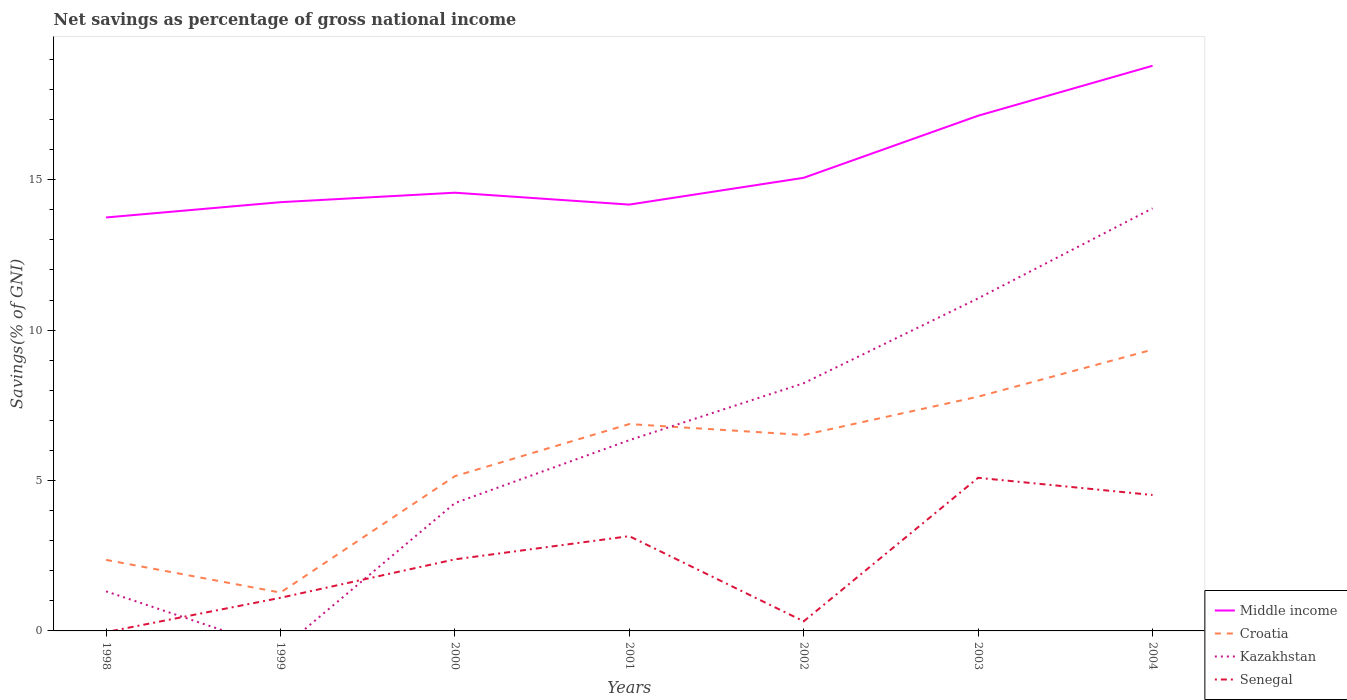Across all years, what is the maximum total savings in Middle income?
Your response must be concise. 13.74. What is the total total savings in Kazakhstan in the graph?
Give a very brief answer. -7.71. What is the difference between the highest and the second highest total savings in Middle income?
Provide a succinct answer. 5.04. Is the total savings in Croatia strictly greater than the total savings in Middle income over the years?
Keep it short and to the point. Yes. What is the difference between two consecutive major ticks on the Y-axis?
Your response must be concise. 5. How are the legend labels stacked?
Your answer should be compact. Vertical. What is the title of the graph?
Your answer should be compact. Net savings as percentage of gross national income. Does "Eritrea" appear as one of the legend labels in the graph?
Make the answer very short. No. What is the label or title of the X-axis?
Provide a short and direct response. Years. What is the label or title of the Y-axis?
Ensure brevity in your answer.  Savings(% of GNI). What is the Savings(% of GNI) of Middle income in 1998?
Provide a short and direct response. 13.74. What is the Savings(% of GNI) in Croatia in 1998?
Your answer should be very brief. 2.36. What is the Savings(% of GNI) of Kazakhstan in 1998?
Ensure brevity in your answer.  1.32. What is the Savings(% of GNI) of Senegal in 1998?
Give a very brief answer. 0. What is the Savings(% of GNI) in Middle income in 1999?
Keep it short and to the point. 14.25. What is the Savings(% of GNI) of Croatia in 1999?
Make the answer very short. 1.28. What is the Savings(% of GNI) of Kazakhstan in 1999?
Ensure brevity in your answer.  0. What is the Savings(% of GNI) in Senegal in 1999?
Provide a succinct answer. 1.1. What is the Savings(% of GNI) in Middle income in 2000?
Provide a succinct answer. 14.57. What is the Savings(% of GNI) in Croatia in 2000?
Keep it short and to the point. 5.14. What is the Savings(% of GNI) of Kazakhstan in 2000?
Give a very brief answer. 4.25. What is the Savings(% of GNI) in Senegal in 2000?
Keep it short and to the point. 2.38. What is the Savings(% of GNI) in Middle income in 2001?
Ensure brevity in your answer.  14.17. What is the Savings(% of GNI) of Croatia in 2001?
Offer a very short reply. 6.88. What is the Savings(% of GNI) in Kazakhstan in 2001?
Your answer should be very brief. 6.34. What is the Savings(% of GNI) of Senegal in 2001?
Your response must be concise. 3.15. What is the Savings(% of GNI) in Middle income in 2002?
Keep it short and to the point. 15.06. What is the Savings(% of GNI) of Croatia in 2002?
Make the answer very short. 6.51. What is the Savings(% of GNI) in Kazakhstan in 2002?
Give a very brief answer. 8.24. What is the Savings(% of GNI) in Senegal in 2002?
Your answer should be very brief. 0.32. What is the Savings(% of GNI) in Middle income in 2003?
Provide a succinct answer. 17.13. What is the Savings(% of GNI) of Croatia in 2003?
Provide a short and direct response. 7.79. What is the Savings(% of GNI) in Kazakhstan in 2003?
Your response must be concise. 11.06. What is the Savings(% of GNI) of Senegal in 2003?
Provide a succinct answer. 5.09. What is the Savings(% of GNI) of Middle income in 2004?
Your response must be concise. 18.79. What is the Savings(% of GNI) of Croatia in 2004?
Make the answer very short. 9.35. What is the Savings(% of GNI) in Kazakhstan in 2004?
Provide a short and direct response. 14.05. What is the Savings(% of GNI) of Senegal in 2004?
Provide a short and direct response. 4.52. Across all years, what is the maximum Savings(% of GNI) in Middle income?
Give a very brief answer. 18.79. Across all years, what is the maximum Savings(% of GNI) in Croatia?
Make the answer very short. 9.35. Across all years, what is the maximum Savings(% of GNI) of Kazakhstan?
Offer a very short reply. 14.05. Across all years, what is the maximum Savings(% of GNI) in Senegal?
Your answer should be compact. 5.09. Across all years, what is the minimum Savings(% of GNI) of Middle income?
Ensure brevity in your answer.  13.74. Across all years, what is the minimum Savings(% of GNI) of Croatia?
Make the answer very short. 1.28. What is the total Savings(% of GNI) of Middle income in the graph?
Make the answer very short. 107.72. What is the total Savings(% of GNI) in Croatia in the graph?
Provide a short and direct response. 39.31. What is the total Savings(% of GNI) in Kazakhstan in the graph?
Keep it short and to the point. 45.24. What is the total Savings(% of GNI) of Senegal in the graph?
Give a very brief answer. 16.56. What is the difference between the Savings(% of GNI) of Middle income in 1998 and that in 1999?
Your answer should be very brief. -0.51. What is the difference between the Savings(% of GNI) of Croatia in 1998 and that in 1999?
Offer a very short reply. 1.09. What is the difference between the Savings(% of GNI) in Middle income in 1998 and that in 2000?
Ensure brevity in your answer.  -0.82. What is the difference between the Savings(% of GNI) in Croatia in 1998 and that in 2000?
Your response must be concise. -2.78. What is the difference between the Savings(% of GNI) of Kazakhstan in 1998 and that in 2000?
Give a very brief answer. -2.93. What is the difference between the Savings(% of GNI) in Middle income in 1998 and that in 2001?
Your response must be concise. -0.43. What is the difference between the Savings(% of GNI) of Croatia in 1998 and that in 2001?
Make the answer very short. -4.52. What is the difference between the Savings(% of GNI) of Kazakhstan in 1998 and that in 2001?
Ensure brevity in your answer.  -5.02. What is the difference between the Savings(% of GNI) in Middle income in 1998 and that in 2002?
Ensure brevity in your answer.  -1.32. What is the difference between the Savings(% of GNI) of Croatia in 1998 and that in 2002?
Offer a terse response. -4.15. What is the difference between the Savings(% of GNI) in Kazakhstan in 1998 and that in 2002?
Your answer should be compact. -6.92. What is the difference between the Savings(% of GNI) in Middle income in 1998 and that in 2003?
Keep it short and to the point. -3.38. What is the difference between the Savings(% of GNI) in Croatia in 1998 and that in 2003?
Give a very brief answer. -5.43. What is the difference between the Savings(% of GNI) in Kazakhstan in 1998 and that in 2003?
Make the answer very short. -9.74. What is the difference between the Savings(% of GNI) in Middle income in 1998 and that in 2004?
Keep it short and to the point. -5.04. What is the difference between the Savings(% of GNI) of Croatia in 1998 and that in 2004?
Make the answer very short. -6.99. What is the difference between the Savings(% of GNI) of Kazakhstan in 1998 and that in 2004?
Offer a terse response. -12.73. What is the difference between the Savings(% of GNI) of Middle income in 1999 and that in 2000?
Provide a short and direct response. -0.32. What is the difference between the Savings(% of GNI) of Croatia in 1999 and that in 2000?
Make the answer very short. -3.87. What is the difference between the Savings(% of GNI) of Senegal in 1999 and that in 2000?
Offer a very short reply. -1.28. What is the difference between the Savings(% of GNI) in Croatia in 1999 and that in 2001?
Provide a short and direct response. -5.6. What is the difference between the Savings(% of GNI) of Senegal in 1999 and that in 2001?
Make the answer very short. -2.05. What is the difference between the Savings(% of GNI) in Middle income in 1999 and that in 2002?
Your response must be concise. -0.81. What is the difference between the Savings(% of GNI) of Croatia in 1999 and that in 2002?
Give a very brief answer. -5.24. What is the difference between the Savings(% of GNI) in Senegal in 1999 and that in 2002?
Provide a succinct answer. 0.78. What is the difference between the Savings(% of GNI) in Middle income in 1999 and that in 2003?
Give a very brief answer. -2.87. What is the difference between the Savings(% of GNI) in Croatia in 1999 and that in 2003?
Provide a short and direct response. -6.51. What is the difference between the Savings(% of GNI) of Senegal in 1999 and that in 2003?
Offer a very short reply. -3.99. What is the difference between the Savings(% of GNI) in Middle income in 1999 and that in 2004?
Offer a terse response. -4.53. What is the difference between the Savings(% of GNI) of Croatia in 1999 and that in 2004?
Make the answer very short. -8.08. What is the difference between the Savings(% of GNI) in Senegal in 1999 and that in 2004?
Your answer should be compact. -3.42. What is the difference between the Savings(% of GNI) in Middle income in 2000 and that in 2001?
Ensure brevity in your answer.  0.4. What is the difference between the Savings(% of GNI) of Croatia in 2000 and that in 2001?
Make the answer very short. -1.73. What is the difference between the Savings(% of GNI) of Kazakhstan in 2000 and that in 2001?
Provide a succinct answer. -2.09. What is the difference between the Savings(% of GNI) in Senegal in 2000 and that in 2001?
Offer a terse response. -0.77. What is the difference between the Savings(% of GNI) of Middle income in 2000 and that in 2002?
Offer a terse response. -0.5. What is the difference between the Savings(% of GNI) in Croatia in 2000 and that in 2002?
Ensure brevity in your answer.  -1.37. What is the difference between the Savings(% of GNI) in Kazakhstan in 2000 and that in 2002?
Provide a short and direct response. -3.99. What is the difference between the Savings(% of GNI) in Senegal in 2000 and that in 2002?
Offer a very short reply. 2.06. What is the difference between the Savings(% of GNI) of Middle income in 2000 and that in 2003?
Offer a very short reply. -2.56. What is the difference between the Savings(% of GNI) of Croatia in 2000 and that in 2003?
Give a very brief answer. -2.64. What is the difference between the Savings(% of GNI) of Kazakhstan in 2000 and that in 2003?
Provide a short and direct response. -6.81. What is the difference between the Savings(% of GNI) of Senegal in 2000 and that in 2003?
Offer a very short reply. -2.71. What is the difference between the Savings(% of GNI) of Middle income in 2000 and that in 2004?
Provide a short and direct response. -4.22. What is the difference between the Savings(% of GNI) of Croatia in 2000 and that in 2004?
Offer a very short reply. -4.21. What is the difference between the Savings(% of GNI) of Kazakhstan in 2000 and that in 2004?
Keep it short and to the point. -9.8. What is the difference between the Savings(% of GNI) in Senegal in 2000 and that in 2004?
Provide a succinct answer. -2.14. What is the difference between the Savings(% of GNI) of Middle income in 2001 and that in 2002?
Offer a terse response. -0.89. What is the difference between the Savings(% of GNI) in Croatia in 2001 and that in 2002?
Ensure brevity in your answer.  0.36. What is the difference between the Savings(% of GNI) in Kazakhstan in 2001 and that in 2002?
Ensure brevity in your answer.  -1.89. What is the difference between the Savings(% of GNI) of Senegal in 2001 and that in 2002?
Give a very brief answer. 2.83. What is the difference between the Savings(% of GNI) in Middle income in 2001 and that in 2003?
Offer a terse response. -2.95. What is the difference between the Savings(% of GNI) of Croatia in 2001 and that in 2003?
Offer a terse response. -0.91. What is the difference between the Savings(% of GNI) in Kazakhstan in 2001 and that in 2003?
Provide a short and direct response. -4.71. What is the difference between the Savings(% of GNI) of Senegal in 2001 and that in 2003?
Offer a terse response. -1.94. What is the difference between the Savings(% of GNI) of Middle income in 2001 and that in 2004?
Provide a short and direct response. -4.61. What is the difference between the Savings(% of GNI) in Croatia in 2001 and that in 2004?
Offer a very short reply. -2.47. What is the difference between the Savings(% of GNI) in Kazakhstan in 2001 and that in 2004?
Provide a short and direct response. -7.71. What is the difference between the Savings(% of GNI) of Senegal in 2001 and that in 2004?
Make the answer very short. -1.37. What is the difference between the Savings(% of GNI) of Middle income in 2002 and that in 2003?
Offer a terse response. -2.06. What is the difference between the Savings(% of GNI) of Croatia in 2002 and that in 2003?
Make the answer very short. -1.27. What is the difference between the Savings(% of GNI) in Kazakhstan in 2002 and that in 2003?
Offer a terse response. -2.82. What is the difference between the Savings(% of GNI) in Senegal in 2002 and that in 2003?
Your answer should be compact. -4.77. What is the difference between the Savings(% of GNI) of Middle income in 2002 and that in 2004?
Make the answer very short. -3.72. What is the difference between the Savings(% of GNI) in Croatia in 2002 and that in 2004?
Make the answer very short. -2.84. What is the difference between the Savings(% of GNI) of Kazakhstan in 2002 and that in 2004?
Make the answer very short. -5.81. What is the difference between the Savings(% of GNI) in Senegal in 2002 and that in 2004?
Give a very brief answer. -4.2. What is the difference between the Savings(% of GNI) of Middle income in 2003 and that in 2004?
Offer a very short reply. -1.66. What is the difference between the Savings(% of GNI) in Croatia in 2003 and that in 2004?
Provide a short and direct response. -1.56. What is the difference between the Savings(% of GNI) in Kazakhstan in 2003 and that in 2004?
Keep it short and to the point. -2.99. What is the difference between the Savings(% of GNI) of Senegal in 2003 and that in 2004?
Keep it short and to the point. 0.57. What is the difference between the Savings(% of GNI) in Middle income in 1998 and the Savings(% of GNI) in Croatia in 1999?
Ensure brevity in your answer.  12.47. What is the difference between the Savings(% of GNI) of Middle income in 1998 and the Savings(% of GNI) of Senegal in 1999?
Your response must be concise. 12.64. What is the difference between the Savings(% of GNI) of Croatia in 1998 and the Savings(% of GNI) of Senegal in 1999?
Your answer should be very brief. 1.26. What is the difference between the Savings(% of GNI) of Kazakhstan in 1998 and the Savings(% of GNI) of Senegal in 1999?
Your response must be concise. 0.22. What is the difference between the Savings(% of GNI) in Middle income in 1998 and the Savings(% of GNI) in Croatia in 2000?
Give a very brief answer. 8.6. What is the difference between the Savings(% of GNI) of Middle income in 1998 and the Savings(% of GNI) of Kazakhstan in 2000?
Ensure brevity in your answer.  9.5. What is the difference between the Savings(% of GNI) in Middle income in 1998 and the Savings(% of GNI) in Senegal in 2000?
Provide a succinct answer. 11.37. What is the difference between the Savings(% of GNI) in Croatia in 1998 and the Savings(% of GNI) in Kazakhstan in 2000?
Your answer should be very brief. -1.89. What is the difference between the Savings(% of GNI) of Croatia in 1998 and the Savings(% of GNI) of Senegal in 2000?
Make the answer very short. -0.02. What is the difference between the Savings(% of GNI) in Kazakhstan in 1998 and the Savings(% of GNI) in Senegal in 2000?
Provide a short and direct response. -1.06. What is the difference between the Savings(% of GNI) of Middle income in 1998 and the Savings(% of GNI) of Croatia in 2001?
Your response must be concise. 6.87. What is the difference between the Savings(% of GNI) of Middle income in 1998 and the Savings(% of GNI) of Kazakhstan in 2001?
Offer a terse response. 7.4. What is the difference between the Savings(% of GNI) in Middle income in 1998 and the Savings(% of GNI) in Senegal in 2001?
Your answer should be very brief. 10.59. What is the difference between the Savings(% of GNI) in Croatia in 1998 and the Savings(% of GNI) in Kazakhstan in 2001?
Your response must be concise. -3.98. What is the difference between the Savings(% of GNI) in Croatia in 1998 and the Savings(% of GNI) in Senegal in 2001?
Your response must be concise. -0.79. What is the difference between the Savings(% of GNI) of Kazakhstan in 1998 and the Savings(% of GNI) of Senegal in 2001?
Offer a very short reply. -1.83. What is the difference between the Savings(% of GNI) of Middle income in 1998 and the Savings(% of GNI) of Croatia in 2002?
Provide a succinct answer. 7.23. What is the difference between the Savings(% of GNI) in Middle income in 1998 and the Savings(% of GNI) in Kazakhstan in 2002?
Give a very brief answer. 5.51. What is the difference between the Savings(% of GNI) of Middle income in 1998 and the Savings(% of GNI) of Senegal in 2002?
Ensure brevity in your answer.  13.43. What is the difference between the Savings(% of GNI) in Croatia in 1998 and the Savings(% of GNI) in Kazakhstan in 2002?
Offer a very short reply. -5.87. What is the difference between the Savings(% of GNI) in Croatia in 1998 and the Savings(% of GNI) in Senegal in 2002?
Give a very brief answer. 2.04. What is the difference between the Savings(% of GNI) in Kazakhstan in 1998 and the Savings(% of GNI) in Senegal in 2002?
Give a very brief answer. 1. What is the difference between the Savings(% of GNI) in Middle income in 1998 and the Savings(% of GNI) in Croatia in 2003?
Offer a very short reply. 5.96. What is the difference between the Savings(% of GNI) in Middle income in 1998 and the Savings(% of GNI) in Kazakhstan in 2003?
Your answer should be very brief. 2.69. What is the difference between the Savings(% of GNI) of Middle income in 1998 and the Savings(% of GNI) of Senegal in 2003?
Your answer should be very brief. 8.65. What is the difference between the Savings(% of GNI) of Croatia in 1998 and the Savings(% of GNI) of Kazakhstan in 2003?
Your answer should be compact. -8.69. What is the difference between the Savings(% of GNI) of Croatia in 1998 and the Savings(% of GNI) of Senegal in 2003?
Give a very brief answer. -2.73. What is the difference between the Savings(% of GNI) in Kazakhstan in 1998 and the Savings(% of GNI) in Senegal in 2003?
Offer a terse response. -3.77. What is the difference between the Savings(% of GNI) in Middle income in 1998 and the Savings(% of GNI) in Croatia in 2004?
Your answer should be compact. 4.39. What is the difference between the Savings(% of GNI) of Middle income in 1998 and the Savings(% of GNI) of Kazakhstan in 2004?
Provide a succinct answer. -0.3. What is the difference between the Savings(% of GNI) of Middle income in 1998 and the Savings(% of GNI) of Senegal in 2004?
Keep it short and to the point. 9.23. What is the difference between the Savings(% of GNI) of Croatia in 1998 and the Savings(% of GNI) of Kazakhstan in 2004?
Give a very brief answer. -11.69. What is the difference between the Savings(% of GNI) in Croatia in 1998 and the Savings(% of GNI) in Senegal in 2004?
Your response must be concise. -2.16. What is the difference between the Savings(% of GNI) of Kazakhstan in 1998 and the Savings(% of GNI) of Senegal in 2004?
Keep it short and to the point. -3.2. What is the difference between the Savings(% of GNI) in Middle income in 1999 and the Savings(% of GNI) in Croatia in 2000?
Make the answer very short. 9.11. What is the difference between the Savings(% of GNI) in Middle income in 1999 and the Savings(% of GNI) in Kazakhstan in 2000?
Give a very brief answer. 10. What is the difference between the Savings(% of GNI) in Middle income in 1999 and the Savings(% of GNI) in Senegal in 2000?
Your answer should be compact. 11.87. What is the difference between the Savings(% of GNI) of Croatia in 1999 and the Savings(% of GNI) of Kazakhstan in 2000?
Make the answer very short. -2.97. What is the difference between the Savings(% of GNI) in Croatia in 1999 and the Savings(% of GNI) in Senegal in 2000?
Ensure brevity in your answer.  -1.1. What is the difference between the Savings(% of GNI) of Middle income in 1999 and the Savings(% of GNI) of Croatia in 2001?
Your response must be concise. 7.38. What is the difference between the Savings(% of GNI) of Middle income in 1999 and the Savings(% of GNI) of Kazakhstan in 2001?
Your response must be concise. 7.91. What is the difference between the Savings(% of GNI) of Middle income in 1999 and the Savings(% of GNI) of Senegal in 2001?
Keep it short and to the point. 11.1. What is the difference between the Savings(% of GNI) of Croatia in 1999 and the Savings(% of GNI) of Kazakhstan in 2001?
Your answer should be compact. -5.07. What is the difference between the Savings(% of GNI) of Croatia in 1999 and the Savings(% of GNI) of Senegal in 2001?
Your answer should be very brief. -1.88. What is the difference between the Savings(% of GNI) in Middle income in 1999 and the Savings(% of GNI) in Croatia in 2002?
Make the answer very short. 7.74. What is the difference between the Savings(% of GNI) of Middle income in 1999 and the Savings(% of GNI) of Kazakhstan in 2002?
Give a very brief answer. 6.02. What is the difference between the Savings(% of GNI) in Middle income in 1999 and the Savings(% of GNI) in Senegal in 2002?
Ensure brevity in your answer.  13.93. What is the difference between the Savings(% of GNI) of Croatia in 1999 and the Savings(% of GNI) of Kazakhstan in 2002?
Your answer should be very brief. -6.96. What is the difference between the Savings(% of GNI) in Croatia in 1999 and the Savings(% of GNI) in Senegal in 2002?
Provide a short and direct response. 0.96. What is the difference between the Savings(% of GNI) in Middle income in 1999 and the Savings(% of GNI) in Croatia in 2003?
Make the answer very short. 6.47. What is the difference between the Savings(% of GNI) of Middle income in 1999 and the Savings(% of GNI) of Kazakhstan in 2003?
Provide a short and direct response. 3.2. What is the difference between the Savings(% of GNI) of Middle income in 1999 and the Savings(% of GNI) of Senegal in 2003?
Keep it short and to the point. 9.16. What is the difference between the Savings(% of GNI) of Croatia in 1999 and the Savings(% of GNI) of Kazakhstan in 2003?
Offer a terse response. -9.78. What is the difference between the Savings(% of GNI) in Croatia in 1999 and the Savings(% of GNI) in Senegal in 2003?
Your response must be concise. -3.82. What is the difference between the Savings(% of GNI) of Middle income in 1999 and the Savings(% of GNI) of Croatia in 2004?
Provide a succinct answer. 4.9. What is the difference between the Savings(% of GNI) of Middle income in 1999 and the Savings(% of GNI) of Kazakhstan in 2004?
Your response must be concise. 0.21. What is the difference between the Savings(% of GNI) in Middle income in 1999 and the Savings(% of GNI) in Senegal in 2004?
Offer a very short reply. 9.73. What is the difference between the Savings(% of GNI) in Croatia in 1999 and the Savings(% of GNI) in Kazakhstan in 2004?
Keep it short and to the point. -12.77. What is the difference between the Savings(% of GNI) of Croatia in 1999 and the Savings(% of GNI) of Senegal in 2004?
Provide a succinct answer. -3.24. What is the difference between the Savings(% of GNI) of Middle income in 2000 and the Savings(% of GNI) of Croatia in 2001?
Offer a terse response. 7.69. What is the difference between the Savings(% of GNI) of Middle income in 2000 and the Savings(% of GNI) of Kazakhstan in 2001?
Ensure brevity in your answer.  8.23. What is the difference between the Savings(% of GNI) of Middle income in 2000 and the Savings(% of GNI) of Senegal in 2001?
Offer a very short reply. 11.42. What is the difference between the Savings(% of GNI) of Croatia in 2000 and the Savings(% of GNI) of Kazakhstan in 2001?
Give a very brief answer. -1.2. What is the difference between the Savings(% of GNI) in Croatia in 2000 and the Savings(% of GNI) in Senegal in 2001?
Offer a very short reply. 1.99. What is the difference between the Savings(% of GNI) in Kazakhstan in 2000 and the Savings(% of GNI) in Senegal in 2001?
Offer a terse response. 1.1. What is the difference between the Savings(% of GNI) in Middle income in 2000 and the Savings(% of GNI) in Croatia in 2002?
Your answer should be very brief. 8.05. What is the difference between the Savings(% of GNI) in Middle income in 2000 and the Savings(% of GNI) in Kazakhstan in 2002?
Offer a very short reply. 6.33. What is the difference between the Savings(% of GNI) in Middle income in 2000 and the Savings(% of GNI) in Senegal in 2002?
Your answer should be compact. 14.25. What is the difference between the Savings(% of GNI) of Croatia in 2000 and the Savings(% of GNI) of Kazakhstan in 2002?
Keep it short and to the point. -3.09. What is the difference between the Savings(% of GNI) of Croatia in 2000 and the Savings(% of GNI) of Senegal in 2002?
Give a very brief answer. 4.83. What is the difference between the Savings(% of GNI) of Kazakhstan in 2000 and the Savings(% of GNI) of Senegal in 2002?
Ensure brevity in your answer.  3.93. What is the difference between the Savings(% of GNI) in Middle income in 2000 and the Savings(% of GNI) in Croatia in 2003?
Make the answer very short. 6.78. What is the difference between the Savings(% of GNI) in Middle income in 2000 and the Savings(% of GNI) in Kazakhstan in 2003?
Your answer should be very brief. 3.51. What is the difference between the Savings(% of GNI) of Middle income in 2000 and the Savings(% of GNI) of Senegal in 2003?
Make the answer very short. 9.48. What is the difference between the Savings(% of GNI) of Croatia in 2000 and the Savings(% of GNI) of Kazakhstan in 2003?
Ensure brevity in your answer.  -5.91. What is the difference between the Savings(% of GNI) of Croatia in 2000 and the Savings(% of GNI) of Senegal in 2003?
Offer a very short reply. 0.05. What is the difference between the Savings(% of GNI) of Kazakhstan in 2000 and the Savings(% of GNI) of Senegal in 2003?
Your answer should be very brief. -0.84. What is the difference between the Savings(% of GNI) of Middle income in 2000 and the Savings(% of GNI) of Croatia in 2004?
Provide a succinct answer. 5.22. What is the difference between the Savings(% of GNI) of Middle income in 2000 and the Savings(% of GNI) of Kazakhstan in 2004?
Keep it short and to the point. 0.52. What is the difference between the Savings(% of GNI) in Middle income in 2000 and the Savings(% of GNI) in Senegal in 2004?
Offer a very short reply. 10.05. What is the difference between the Savings(% of GNI) in Croatia in 2000 and the Savings(% of GNI) in Kazakhstan in 2004?
Provide a short and direct response. -8.9. What is the difference between the Savings(% of GNI) in Croatia in 2000 and the Savings(% of GNI) in Senegal in 2004?
Give a very brief answer. 0.63. What is the difference between the Savings(% of GNI) of Kazakhstan in 2000 and the Savings(% of GNI) of Senegal in 2004?
Offer a terse response. -0.27. What is the difference between the Savings(% of GNI) in Middle income in 2001 and the Savings(% of GNI) in Croatia in 2002?
Give a very brief answer. 7.66. What is the difference between the Savings(% of GNI) in Middle income in 2001 and the Savings(% of GNI) in Kazakhstan in 2002?
Your answer should be very brief. 5.94. What is the difference between the Savings(% of GNI) in Middle income in 2001 and the Savings(% of GNI) in Senegal in 2002?
Your response must be concise. 13.85. What is the difference between the Savings(% of GNI) in Croatia in 2001 and the Savings(% of GNI) in Kazakhstan in 2002?
Offer a terse response. -1.36. What is the difference between the Savings(% of GNI) of Croatia in 2001 and the Savings(% of GNI) of Senegal in 2002?
Provide a short and direct response. 6.56. What is the difference between the Savings(% of GNI) of Kazakhstan in 2001 and the Savings(% of GNI) of Senegal in 2002?
Ensure brevity in your answer.  6.02. What is the difference between the Savings(% of GNI) of Middle income in 2001 and the Savings(% of GNI) of Croatia in 2003?
Keep it short and to the point. 6.39. What is the difference between the Savings(% of GNI) of Middle income in 2001 and the Savings(% of GNI) of Kazakhstan in 2003?
Give a very brief answer. 3.12. What is the difference between the Savings(% of GNI) of Middle income in 2001 and the Savings(% of GNI) of Senegal in 2003?
Your answer should be compact. 9.08. What is the difference between the Savings(% of GNI) of Croatia in 2001 and the Savings(% of GNI) of Kazakhstan in 2003?
Your response must be concise. -4.18. What is the difference between the Savings(% of GNI) in Croatia in 2001 and the Savings(% of GNI) in Senegal in 2003?
Keep it short and to the point. 1.79. What is the difference between the Savings(% of GNI) of Kazakhstan in 2001 and the Savings(% of GNI) of Senegal in 2003?
Keep it short and to the point. 1.25. What is the difference between the Savings(% of GNI) of Middle income in 2001 and the Savings(% of GNI) of Croatia in 2004?
Give a very brief answer. 4.82. What is the difference between the Savings(% of GNI) in Middle income in 2001 and the Savings(% of GNI) in Kazakhstan in 2004?
Your answer should be compact. 0.13. What is the difference between the Savings(% of GNI) in Middle income in 2001 and the Savings(% of GNI) in Senegal in 2004?
Your response must be concise. 9.65. What is the difference between the Savings(% of GNI) of Croatia in 2001 and the Savings(% of GNI) of Kazakhstan in 2004?
Keep it short and to the point. -7.17. What is the difference between the Savings(% of GNI) of Croatia in 2001 and the Savings(% of GNI) of Senegal in 2004?
Your response must be concise. 2.36. What is the difference between the Savings(% of GNI) of Kazakhstan in 2001 and the Savings(% of GNI) of Senegal in 2004?
Give a very brief answer. 1.82. What is the difference between the Savings(% of GNI) of Middle income in 2002 and the Savings(% of GNI) of Croatia in 2003?
Your answer should be compact. 7.28. What is the difference between the Savings(% of GNI) of Middle income in 2002 and the Savings(% of GNI) of Kazakhstan in 2003?
Ensure brevity in your answer.  4.01. What is the difference between the Savings(% of GNI) of Middle income in 2002 and the Savings(% of GNI) of Senegal in 2003?
Provide a short and direct response. 9.97. What is the difference between the Savings(% of GNI) of Croatia in 2002 and the Savings(% of GNI) of Kazakhstan in 2003?
Make the answer very short. -4.54. What is the difference between the Savings(% of GNI) of Croatia in 2002 and the Savings(% of GNI) of Senegal in 2003?
Your answer should be compact. 1.42. What is the difference between the Savings(% of GNI) in Kazakhstan in 2002 and the Savings(% of GNI) in Senegal in 2003?
Ensure brevity in your answer.  3.14. What is the difference between the Savings(% of GNI) in Middle income in 2002 and the Savings(% of GNI) in Croatia in 2004?
Provide a short and direct response. 5.71. What is the difference between the Savings(% of GNI) of Middle income in 2002 and the Savings(% of GNI) of Kazakhstan in 2004?
Offer a terse response. 1.02. What is the difference between the Savings(% of GNI) in Middle income in 2002 and the Savings(% of GNI) in Senegal in 2004?
Provide a succinct answer. 10.54. What is the difference between the Savings(% of GNI) in Croatia in 2002 and the Savings(% of GNI) in Kazakhstan in 2004?
Your response must be concise. -7.53. What is the difference between the Savings(% of GNI) of Croatia in 2002 and the Savings(% of GNI) of Senegal in 2004?
Ensure brevity in your answer.  2. What is the difference between the Savings(% of GNI) of Kazakhstan in 2002 and the Savings(% of GNI) of Senegal in 2004?
Keep it short and to the point. 3.72. What is the difference between the Savings(% of GNI) in Middle income in 2003 and the Savings(% of GNI) in Croatia in 2004?
Provide a short and direct response. 7.78. What is the difference between the Savings(% of GNI) in Middle income in 2003 and the Savings(% of GNI) in Kazakhstan in 2004?
Your answer should be compact. 3.08. What is the difference between the Savings(% of GNI) in Middle income in 2003 and the Savings(% of GNI) in Senegal in 2004?
Provide a succinct answer. 12.61. What is the difference between the Savings(% of GNI) of Croatia in 2003 and the Savings(% of GNI) of Kazakhstan in 2004?
Your answer should be compact. -6.26. What is the difference between the Savings(% of GNI) in Croatia in 2003 and the Savings(% of GNI) in Senegal in 2004?
Your answer should be compact. 3.27. What is the difference between the Savings(% of GNI) in Kazakhstan in 2003 and the Savings(% of GNI) in Senegal in 2004?
Give a very brief answer. 6.54. What is the average Savings(% of GNI) of Middle income per year?
Your answer should be compact. 15.39. What is the average Savings(% of GNI) of Croatia per year?
Provide a succinct answer. 5.62. What is the average Savings(% of GNI) of Kazakhstan per year?
Make the answer very short. 6.46. What is the average Savings(% of GNI) in Senegal per year?
Provide a succinct answer. 2.37. In the year 1998, what is the difference between the Savings(% of GNI) in Middle income and Savings(% of GNI) in Croatia?
Ensure brevity in your answer.  11.38. In the year 1998, what is the difference between the Savings(% of GNI) in Middle income and Savings(% of GNI) in Kazakhstan?
Provide a succinct answer. 12.43. In the year 1998, what is the difference between the Savings(% of GNI) in Croatia and Savings(% of GNI) in Kazakhstan?
Provide a succinct answer. 1.05. In the year 1999, what is the difference between the Savings(% of GNI) in Middle income and Savings(% of GNI) in Croatia?
Provide a succinct answer. 12.98. In the year 1999, what is the difference between the Savings(% of GNI) of Middle income and Savings(% of GNI) of Senegal?
Offer a terse response. 13.15. In the year 1999, what is the difference between the Savings(% of GNI) in Croatia and Savings(% of GNI) in Senegal?
Keep it short and to the point. 0.17. In the year 2000, what is the difference between the Savings(% of GNI) in Middle income and Savings(% of GNI) in Croatia?
Offer a terse response. 9.42. In the year 2000, what is the difference between the Savings(% of GNI) in Middle income and Savings(% of GNI) in Kazakhstan?
Offer a terse response. 10.32. In the year 2000, what is the difference between the Savings(% of GNI) in Middle income and Savings(% of GNI) in Senegal?
Offer a terse response. 12.19. In the year 2000, what is the difference between the Savings(% of GNI) of Croatia and Savings(% of GNI) of Kazakhstan?
Provide a succinct answer. 0.9. In the year 2000, what is the difference between the Savings(% of GNI) of Croatia and Savings(% of GNI) of Senegal?
Offer a terse response. 2.76. In the year 2000, what is the difference between the Savings(% of GNI) in Kazakhstan and Savings(% of GNI) in Senegal?
Keep it short and to the point. 1.87. In the year 2001, what is the difference between the Savings(% of GNI) of Middle income and Savings(% of GNI) of Croatia?
Provide a succinct answer. 7.3. In the year 2001, what is the difference between the Savings(% of GNI) in Middle income and Savings(% of GNI) in Kazakhstan?
Your answer should be compact. 7.83. In the year 2001, what is the difference between the Savings(% of GNI) in Middle income and Savings(% of GNI) in Senegal?
Offer a terse response. 11.02. In the year 2001, what is the difference between the Savings(% of GNI) of Croatia and Savings(% of GNI) of Kazakhstan?
Give a very brief answer. 0.54. In the year 2001, what is the difference between the Savings(% of GNI) in Croatia and Savings(% of GNI) in Senegal?
Your response must be concise. 3.73. In the year 2001, what is the difference between the Savings(% of GNI) in Kazakhstan and Savings(% of GNI) in Senegal?
Provide a short and direct response. 3.19. In the year 2002, what is the difference between the Savings(% of GNI) in Middle income and Savings(% of GNI) in Croatia?
Your answer should be very brief. 8.55. In the year 2002, what is the difference between the Savings(% of GNI) in Middle income and Savings(% of GNI) in Kazakhstan?
Keep it short and to the point. 6.83. In the year 2002, what is the difference between the Savings(% of GNI) in Middle income and Savings(% of GNI) in Senegal?
Provide a short and direct response. 14.75. In the year 2002, what is the difference between the Savings(% of GNI) in Croatia and Savings(% of GNI) in Kazakhstan?
Offer a very short reply. -1.72. In the year 2002, what is the difference between the Savings(% of GNI) of Croatia and Savings(% of GNI) of Senegal?
Keep it short and to the point. 6.2. In the year 2002, what is the difference between the Savings(% of GNI) of Kazakhstan and Savings(% of GNI) of Senegal?
Keep it short and to the point. 7.92. In the year 2003, what is the difference between the Savings(% of GNI) in Middle income and Savings(% of GNI) in Croatia?
Your response must be concise. 9.34. In the year 2003, what is the difference between the Savings(% of GNI) in Middle income and Savings(% of GNI) in Kazakhstan?
Offer a very short reply. 6.07. In the year 2003, what is the difference between the Savings(% of GNI) in Middle income and Savings(% of GNI) in Senegal?
Provide a succinct answer. 12.04. In the year 2003, what is the difference between the Savings(% of GNI) of Croatia and Savings(% of GNI) of Kazakhstan?
Make the answer very short. -3.27. In the year 2003, what is the difference between the Savings(% of GNI) of Croatia and Savings(% of GNI) of Senegal?
Provide a short and direct response. 2.7. In the year 2003, what is the difference between the Savings(% of GNI) of Kazakhstan and Savings(% of GNI) of Senegal?
Provide a succinct answer. 5.97. In the year 2004, what is the difference between the Savings(% of GNI) of Middle income and Savings(% of GNI) of Croatia?
Make the answer very short. 9.44. In the year 2004, what is the difference between the Savings(% of GNI) in Middle income and Savings(% of GNI) in Kazakhstan?
Give a very brief answer. 4.74. In the year 2004, what is the difference between the Savings(% of GNI) in Middle income and Savings(% of GNI) in Senegal?
Your answer should be very brief. 14.27. In the year 2004, what is the difference between the Savings(% of GNI) of Croatia and Savings(% of GNI) of Kazakhstan?
Ensure brevity in your answer.  -4.7. In the year 2004, what is the difference between the Savings(% of GNI) in Croatia and Savings(% of GNI) in Senegal?
Provide a short and direct response. 4.83. In the year 2004, what is the difference between the Savings(% of GNI) in Kazakhstan and Savings(% of GNI) in Senegal?
Provide a succinct answer. 9.53. What is the ratio of the Savings(% of GNI) of Middle income in 1998 to that in 1999?
Your answer should be very brief. 0.96. What is the ratio of the Savings(% of GNI) in Croatia in 1998 to that in 1999?
Provide a short and direct response. 1.85. What is the ratio of the Savings(% of GNI) in Middle income in 1998 to that in 2000?
Your response must be concise. 0.94. What is the ratio of the Savings(% of GNI) of Croatia in 1998 to that in 2000?
Your answer should be compact. 0.46. What is the ratio of the Savings(% of GNI) in Kazakhstan in 1998 to that in 2000?
Your answer should be compact. 0.31. What is the ratio of the Savings(% of GNI) of Middle income in 1998 to that in 2001?
Offer a terse response. 0.97. What is the ratio of the Savings(% of GNI) of Croatia in 1998 to that in 2001?
Give a very brief answer. 0.34. What is the ratio of the Savings(% of GNI) in Kazakhstan in 1998 to that in 2001?
Offer a terse response. 0.21. What is the ratio of the Savings(% of GNI) of Middle income in 1998 to that in 2002?
Provide a succinct answer. 0.91. What is the ratio of the Savings(% of GNI) in Croatia in 1998 to that in 2002?
Offer a very short reply. 0.36. What is the ratio of the Savings(% of GNI) of Kazakhstan in 1998 to that in 2002?
Your answer should be compact. 0.16. What is the ratio of the Savings(% of GNI) in Middle income in 1998 to that in 2003?
Your answer should be compact. 0.8. What is the ratio of the Savings(% of GNI) in Croatia in 1998 to that in 2003?
Your answer should be very brief. 0.3. What is the ratio of the Savings(% of GNI) of Kazakhstan in 1998 to that in 2003?
Keep it short and to the point. 0.12. What is the ratio of the Savings(% of GNI) in Middle income in 1998 to that in 2004?
Provide a succinct answer. 0.73. What is the ratio of the Savings(% of GNI) in Croatia in 1998 to that in 2004?
Offer a terse response. 0.25. What is the ratio of the Savings(% of GNI) in Kazakhstan in 1998 to that in 2004?
Ensure brevity in your answer.  0.09. What is the ratio of the Savings(% of GNI) in Middle income in 1999 to that in 2000?
Your answer should be compact. 0.98. What is the ratio of the Savings(% of GNI) in Croatia in 1999 to that in 2000?
Make the answer very short. 0.25. What is the ratio of the Savings(% of GNI) of Senegal in 1999 to that in 2000?
Your answer should be compact. 0.46. What is the ratio of the Savings(% of GNI) of Middle income in 1999 to that in 2001?
Provide a short and direct response. 1.01. What is the ratio of the Savings(% of GNI) of Croatia in 1999 to that in 2001?
Your response must be concise. 0.19. What is the ratio of the Savings(% of GNI) of Senegal in 1999 to that in 2001?
Your response must be concise. 0.35. What is the ratio of the Savings(% of GNI) of Middle income in 1999 to that in 2002?
Provide a short and direct response. 0.95. What is the ratio of the Savings(% of GNI) in Croatia in 1999 to that in 2002?
Ensure brevity in your answer.  0.2. What is the ratio of the Savings(% of GNI) of Senegal in 1999 to that in 2002?
Your answer should be compact. 3.46. What is the ratio of the Savings(% of GNI) in Middle income in 1999 to that in 2003?
Your answer should be compact. 0.83. What is the ratio of the Savings(% of GNI) of Croatia in 1999 to that in 2003?
Your answer should be compact. 0.16. What is the ratio of the Savings(% of GNI) in Senegal in 1999 to that in 2003?
Offer a very short reply. 0.22. What is the ratio of the Savings(% of GNI) in Middle income in 1999 to that in 2004?
Your response must be concise. 0.76. What is the ratio of the Savings(% of GNI) in Croatia in 1999 to that in 2004?
Make the answer very short. 0.14. What is the ratio of the Savings(% of GNI) in Senegal in 1999 to that in 2004?
Provide a short and direct response. 0.24. What is the ratio of the Savings(% of GNI) of Middle income in 2000 to that in 2001?
Give a very brief answer. 1.03. What is the ratio of the Savings(% of GNI) of Croatia in 2000 to that in 2001?
Your answer should be very brief. 0.75. What is the ratio of the Savings(% of GNI) in Kazakhstan in 2000 to that in 2001?
Your response must be concise. 0.67. What is the ratio of the Savings(% of GNI) in Senegal in 2000 to that in 2001?
Make the answer very short. 0.76. What is the ratio of the Savings(% of GNI) in Middle income in 2000 to that in 2002?
Your answer should be very brief. 0.97. What is the ratio of the Savings(% of GNI) in Croatia in 2000 to that in 2002?
Keep it short and to the point. 0.79. What is the ratio of the Savings(% of GNI) in Kazakhstan in 2000 to that in 2002?
Ensure brevity in your answer.  0.52. What is the ratio of the Savings(% of GNI) of Senegal in 2000 to that in 2002?
Give a very brief answer. 7.47. What is the ratio of the Savings(% of GNI) of Middle income in 2000 to that in 2003?
Your response must be concise. 0.85. What is the ratio of the Savings(% of GNI) in Croatia in 2000 to that in 2003?
Your answer should be very brief. 0.66. What is the ratio of the Savings(% of GNI) of Kazakhstan in 2000 to that in 2003?
Provide a succinct answer. 0.38. What is the ratio of the Savings(% of GNI) in Senegal in 2000 to that in 2003?
Ensure brevity in your answer.  0.47. What is the ratio of the Savings(% of GNI) in Middle income in 2000 to that in 2004?
Offer a very short reply. 0.78. What is the ratio of the Savings(% of GNI) in Croatia in 2000 to that in 2004?
Give a very brief answer. 0.55. What is the ratio of the Savings(% of GNI) of Kazakhstan in 2000 to that in 2004?
Ensure brevity in your answer.  0.3. What is the ratio of the Savings(% of GNI) in Senegal in 2000 to that in 2004?
Offer a very short reply. 0.53. What is the ratio of the Savings(% of GNI) in Middle income in 2001 to that in 2002?
Your response must be concise. 0.94. What is the ratio of the Savings(% of GNI) in Croatia in 2001 to that in 2002?
Provide a short and direct response. 1.06. What is the ratio of the Savings(% of GNI) in Kazakhstan in 2001 to that in 2002?
Your answer should be compact. 0.77. What is the ratio of the Savings(% of GNI) in Senegal in 2001 to that in 2002?
Give a very brief answer. 9.89. What is the ratio of the Savings(% of GNI) in Middle income in 2001 to that in 2003?
Make the answer very short. 0.83. What is the ratio of the Savings(% of GNI) of Croatia in 2001 to that in 2003?
Offer a terse response. 0.88. What is the ratio of the Savings(% of GNI) of Kazakhstan in 2001 to that in 2003?
Provide a succinct answer. 0.57. What is the ratio of the Savings(% of GNI) of Senegal in 2001 to that in 2003?
Give a very brief answer. 0.62. What is the ratio of the Savings(% of GNI) in Middle income in 2001 to that in 2004?
Provide a succinct answer. 0.75. What is the ratio of the Savings(% of GNI) of Croatia in 2001 to that in 2004?
Provide a succinct answer. 0.74. What is the ratio of the Savings(% of GNI) of Kazakhstan in 2001 to that in 2004?
Provide a succinct answer. 0.45. What is the ratio of the Savings(% of GNI) of Senegal in 2001 to that in 2004?
Provide a succinct answer. 0.7. What is the ratio of the Savings(% of GNI) in Middle income in 2002 to that in 2003?
Make the answer very short. 0.88. What is the ratio of the Savings(% of GNI) in Croatia in 2002 to that in 2003?
Offer a terse response. 0.84. What is the ratio of the Savings(% of GNI) of Kazakhstan in 2002 to that in 2003?
Your answer should be compact. 0.74. What is the ratio of the Savings(% of GNI) of Senegal in 2002 to that in 2003?
Your response must be concise. 0.06. What is the ratio of the Savings(% of GNI) of Middle income in 2002 to that in 2004?
Your answer should be very brief. 0.8. What is the ratio of the Savings(% of GNI) of Croatia in 2002 to that in 2004?
Ensure brevity in your answer.  0.7. What is the ratio of the Savings(% of GNI) of Kazakhstan in 2002 to that in 2004?
Keep it short and to the point. 0.59. What is the ratio of the Savings(% of GNI) in Senegal in 2002 to that in 2004?
Ensure brevity in your answer.  0.07. What is the ratio of the Savings(% of GNI) in Middle income in 2003 to that in 2004?
Your answer should be compact. 0.91. What is the ratio of the Savings(% of GNI) in Croatia in 2003 to that in 2004?
Offer a terse response. 0.83. What is the ratio of the Savings(% of GNI) in Kazakhstan in 2003 to that in 2004?
Your response must be concise. 0.79. What is the ratio of the Savings(% of GNI) in Senegal in 2003 to that in 2004?
Make the answer very short. 1.13. What is the difference between the highest and the second highest Savings(% of GNI) of Middle income?
Ensure brevity in your answer.  1.66. What is the difference between the highest and the second highest Savings(% of GNI) in Croatia?
Give a very brief answer. 1.56. What is the difference between the highest and the second highest Savings(% of GNI) of Kazakhstan?
Your response must be concise. 2.99. What is the difference between the highest and the second highest Savings(% of GNI) in Senegal?
Your response must be concise. 0.57. What is the difference between the highest and the lowest Savings(% of GNI) in Middle income?
Provide a short and direct response. 5.04. What is the difference between the highest and the lowest Savings(% of GNI) in Croatia?
Keep it short and to the point. 8.08. What is the difference between the highest and the lowest Savings(% of GNI) in Kazakhstan?
Your answer should be very brief. 14.05. What is the difference between the highest and the lowest Savings(% of GNI) of Senegal?
Ensure brevity in your answer.  5.09. 